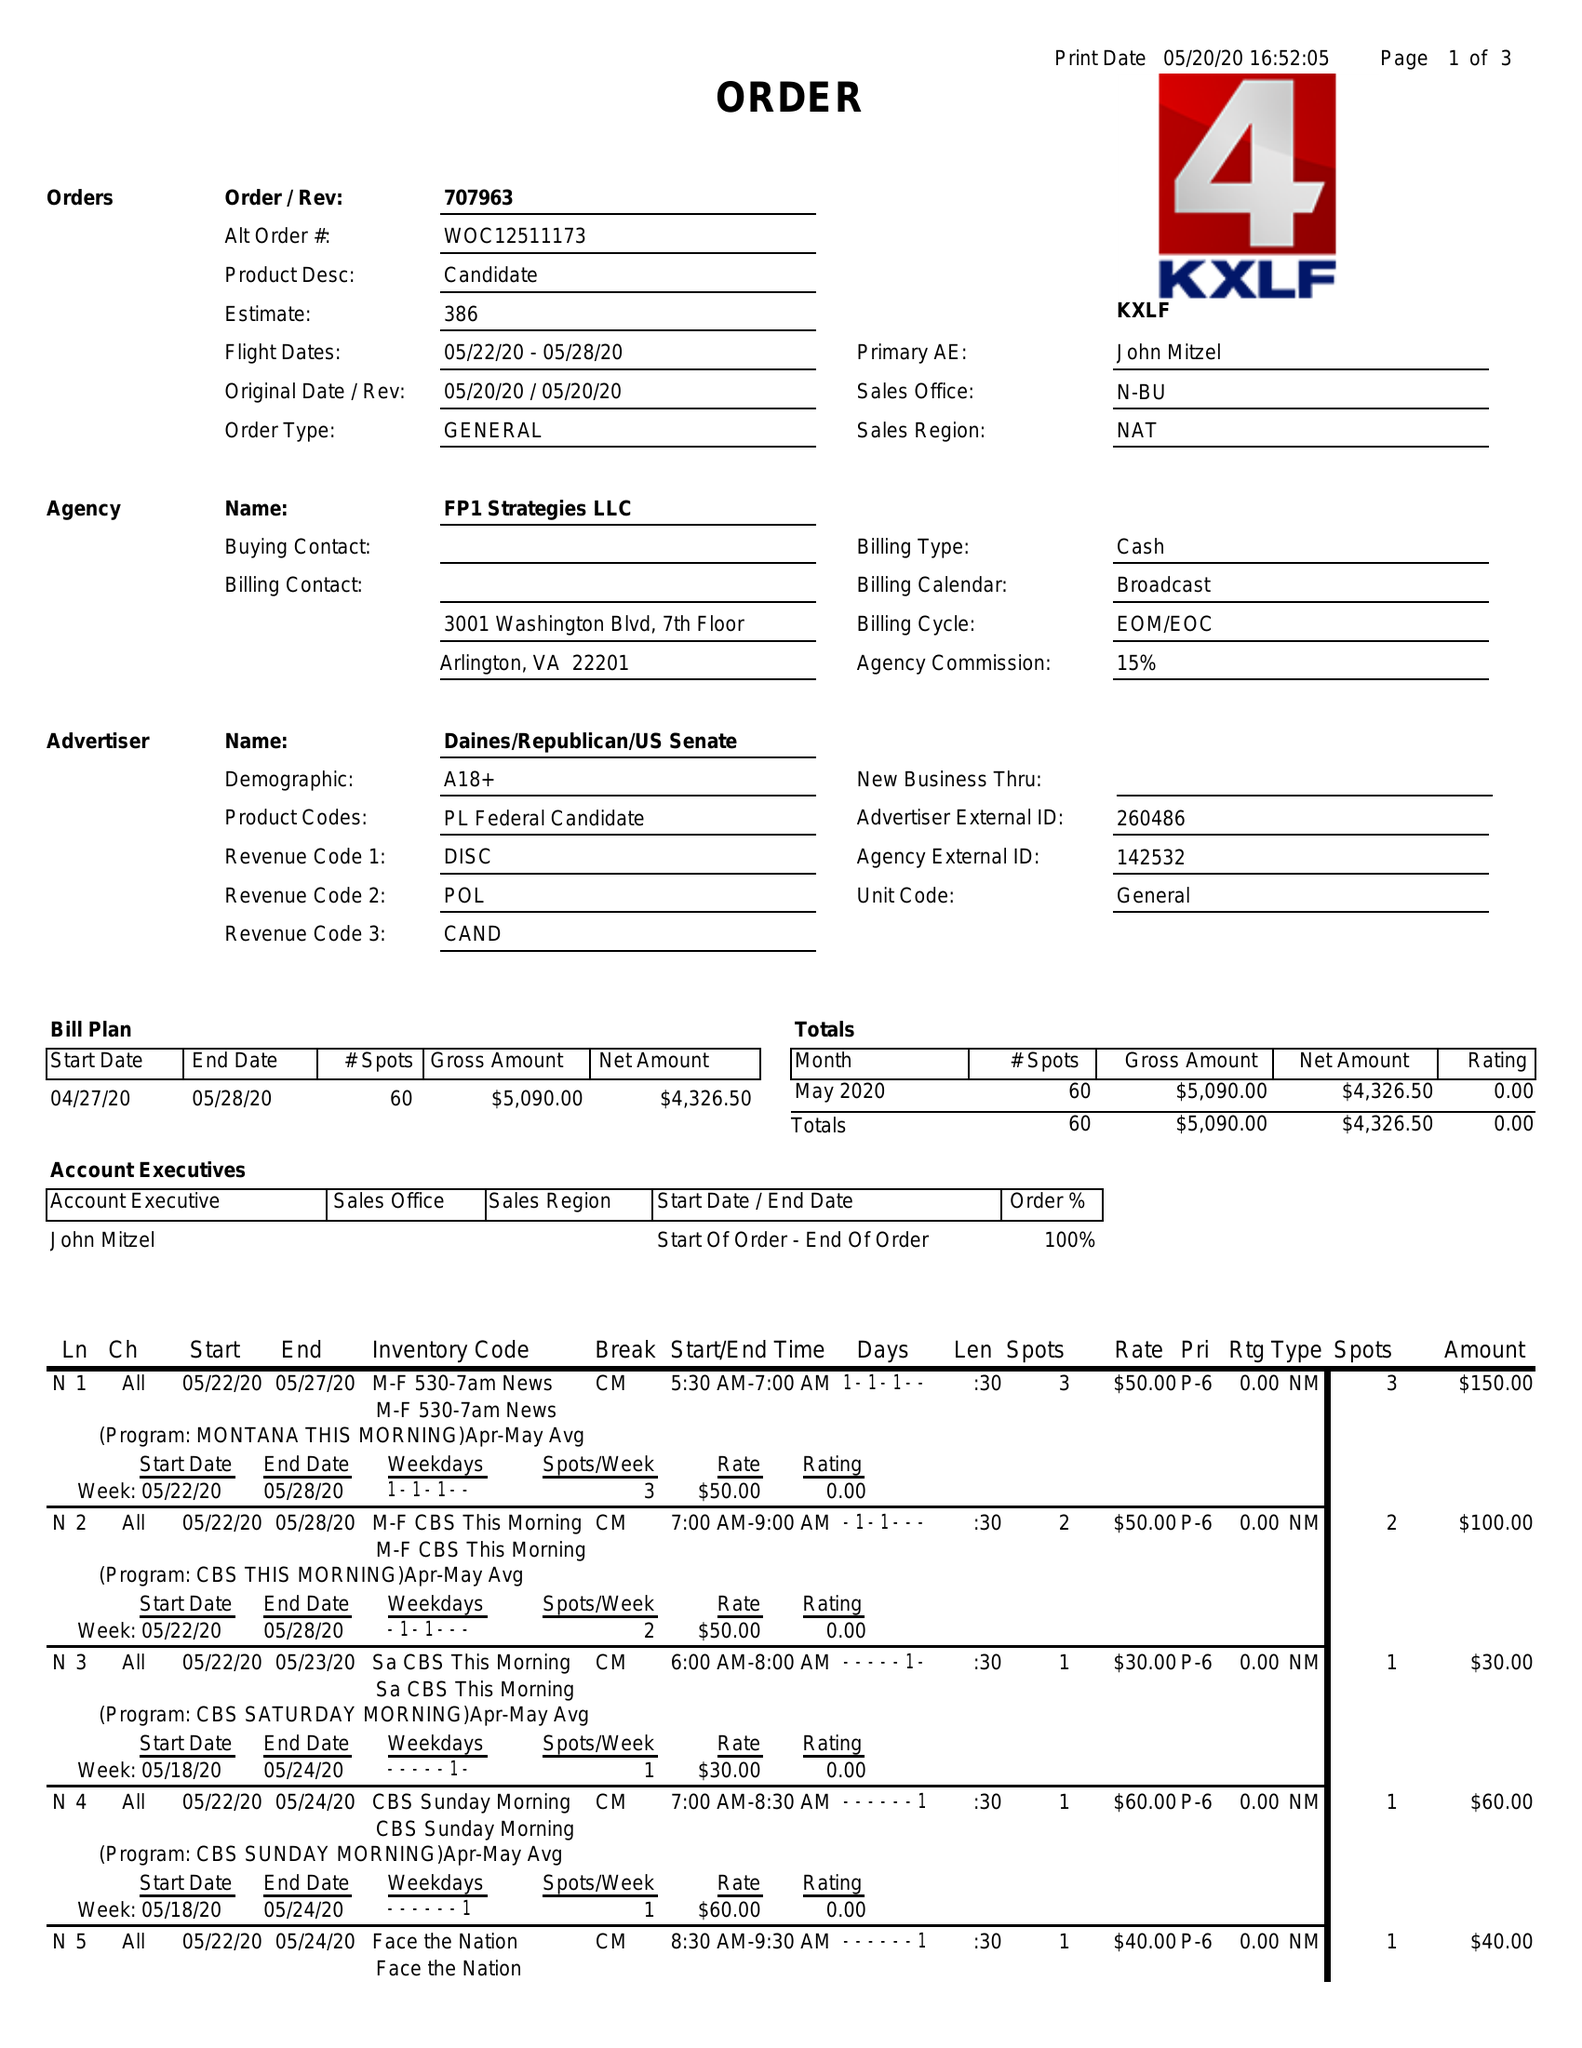What is the value for the flight_from?
Answer the question using a single word or phrase. 05/22/20 